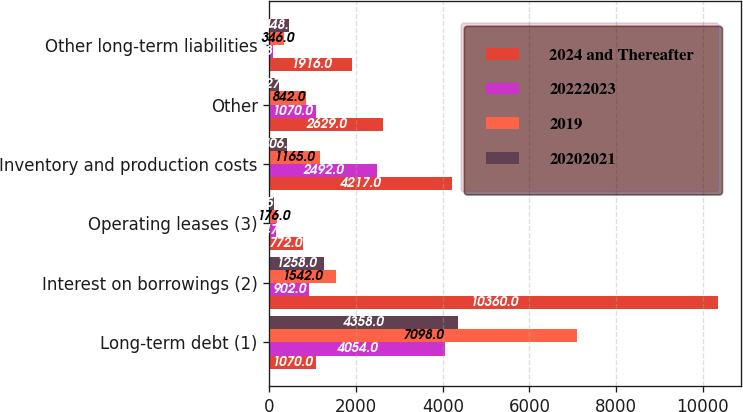Convert chart to OTSL. <chart><loc_0><loc_0><loc_500><loc_500><stacked_bar_chart><ecel><fcel>Long-term debt (1)<fcel>Interest on borrowings (2)<fcel>Operating leases (3)<fcel>Inventory and production costs<fcel>Other<fcel>Other long-term liabilities<nl><fcel>2024 and Thereafter<fcel>1070<fcel>10360<fcel>772<fcel>4217<fcel>2629<fcel>1916<nl><fcel>20222023<fcel>4054<fcel>902<fcel>147<fcel>2492<fcel>1070<fcel>78<nl><fcel>2019<fcel>7098<fcel>1542<fcel>176<fcel>1165<fcel>842<fcel>346<nl><fcel>20202021<fcel>4358<fcel>1258<fcel>95<fcel>406<fcel>227<fcel>448<nl></chart> 